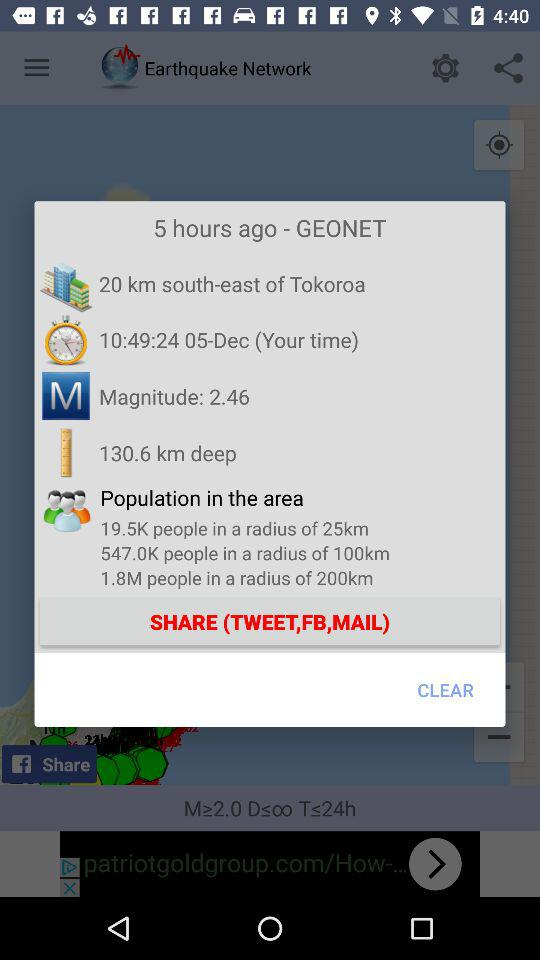How many kilometers deep is the earthquake?
Answer the question using a single word or phrase. 130.6 